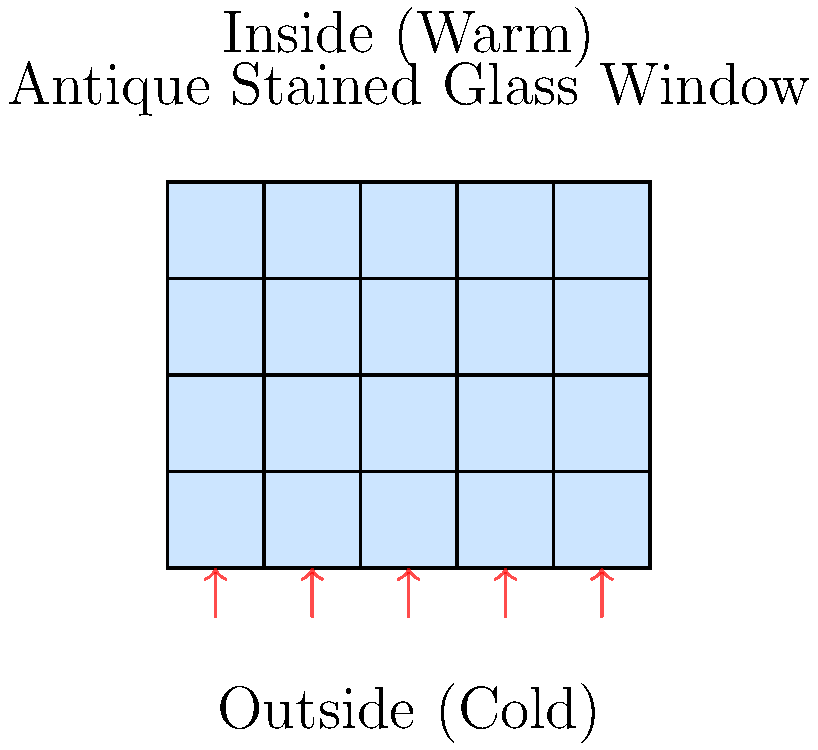An antique stained glass window in your boutique hotel measures 2.5 m × 2 m and is composed of multiple small glass panes. The indoor temperature is maintained at 22°C, while the outdoor temperature is 5°C. If the overall heat transfer coefficient (U-value) of the window is 5.2 W/(m²·K), what is the rate of heat loss through the window? To calculate the rate of heat loss through the antique stained glass window, we'll use the heat transfer equation:

$$Q = U \cdot A \cdot \Delta T$$

Where:
- $Q$ is the rate of heat transfer (W)
- $U$ is the overall heat transfer coefficient (W/(m²·K))
- $A$ is the area of the window (m²)
- $\Delta T$ is the temperature difference between inside and outside (K or °C)

Step 1: Calculate the area of the window
$$A = 2.5 \text{ m} \times 2 \text{ m} = 5 \text{ m}^2$$

Step 2: Calculate the temperature difference
$$\Delta T = 22°C - 5°C = 17°C$$

Step 3: Apply the heat transfer equation
$$Q = 5.2 \text{ W/(m}^2\text{·K)} \times 5 \text{ m}^2 \times 17°C$$

Step 4: Calculate the result
$$Q = 442 \text{ W}$$

Therefore, the rate of heat loss through the antique stained glass window is 442 W.
Answer: 442 W 